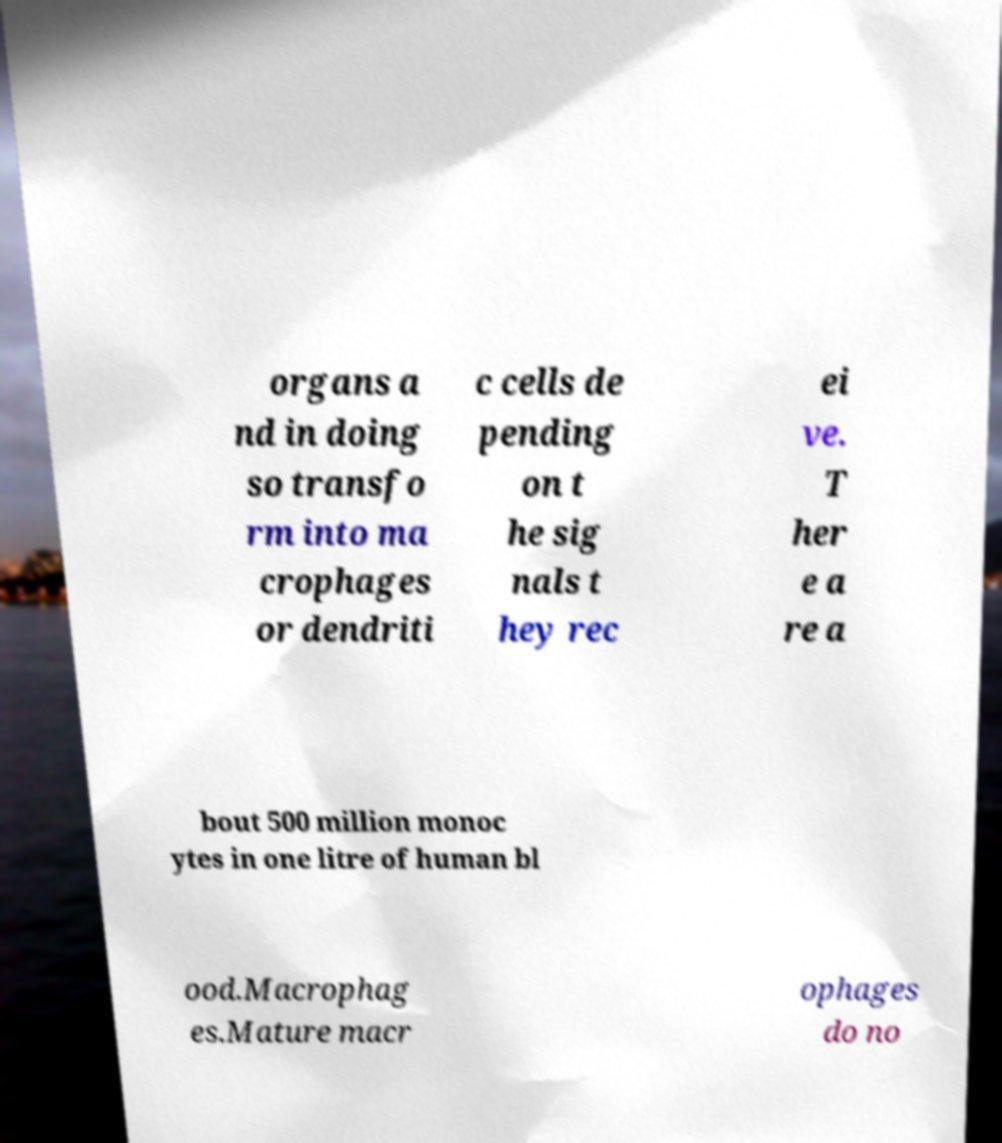Can you read and provide the text displayed in the image?This photo seems to have some interesting text. Can you extract and type it out for me? organs a nd in doing so transfo rm into ma crophages or dendriti c cells de pending on t he sig nals t hey rec ei ve. T her e a re a bout 500 million monoc ytes in one litre of human bl ood.Macrophag es.Mature macr ophages do no 